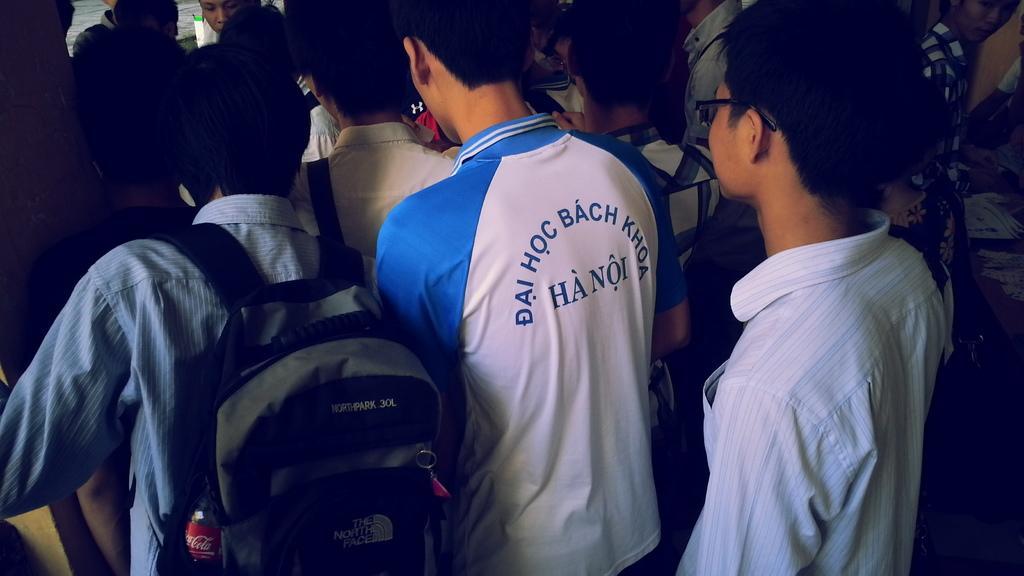Describe this image in one or two sentences. In this picture there are some people. We can observe a person holding a bag on his shoulders which is in black color. On the right side we can observe a boy wearing spectacles. All of them were men. 